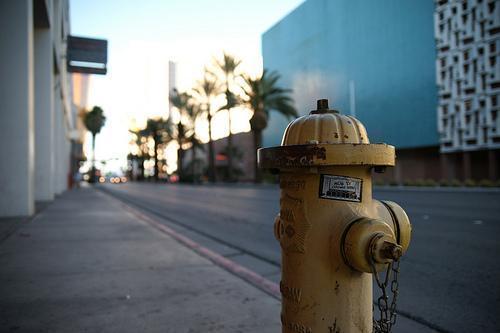How many hydrants?
Give a very brief answer. 1. 